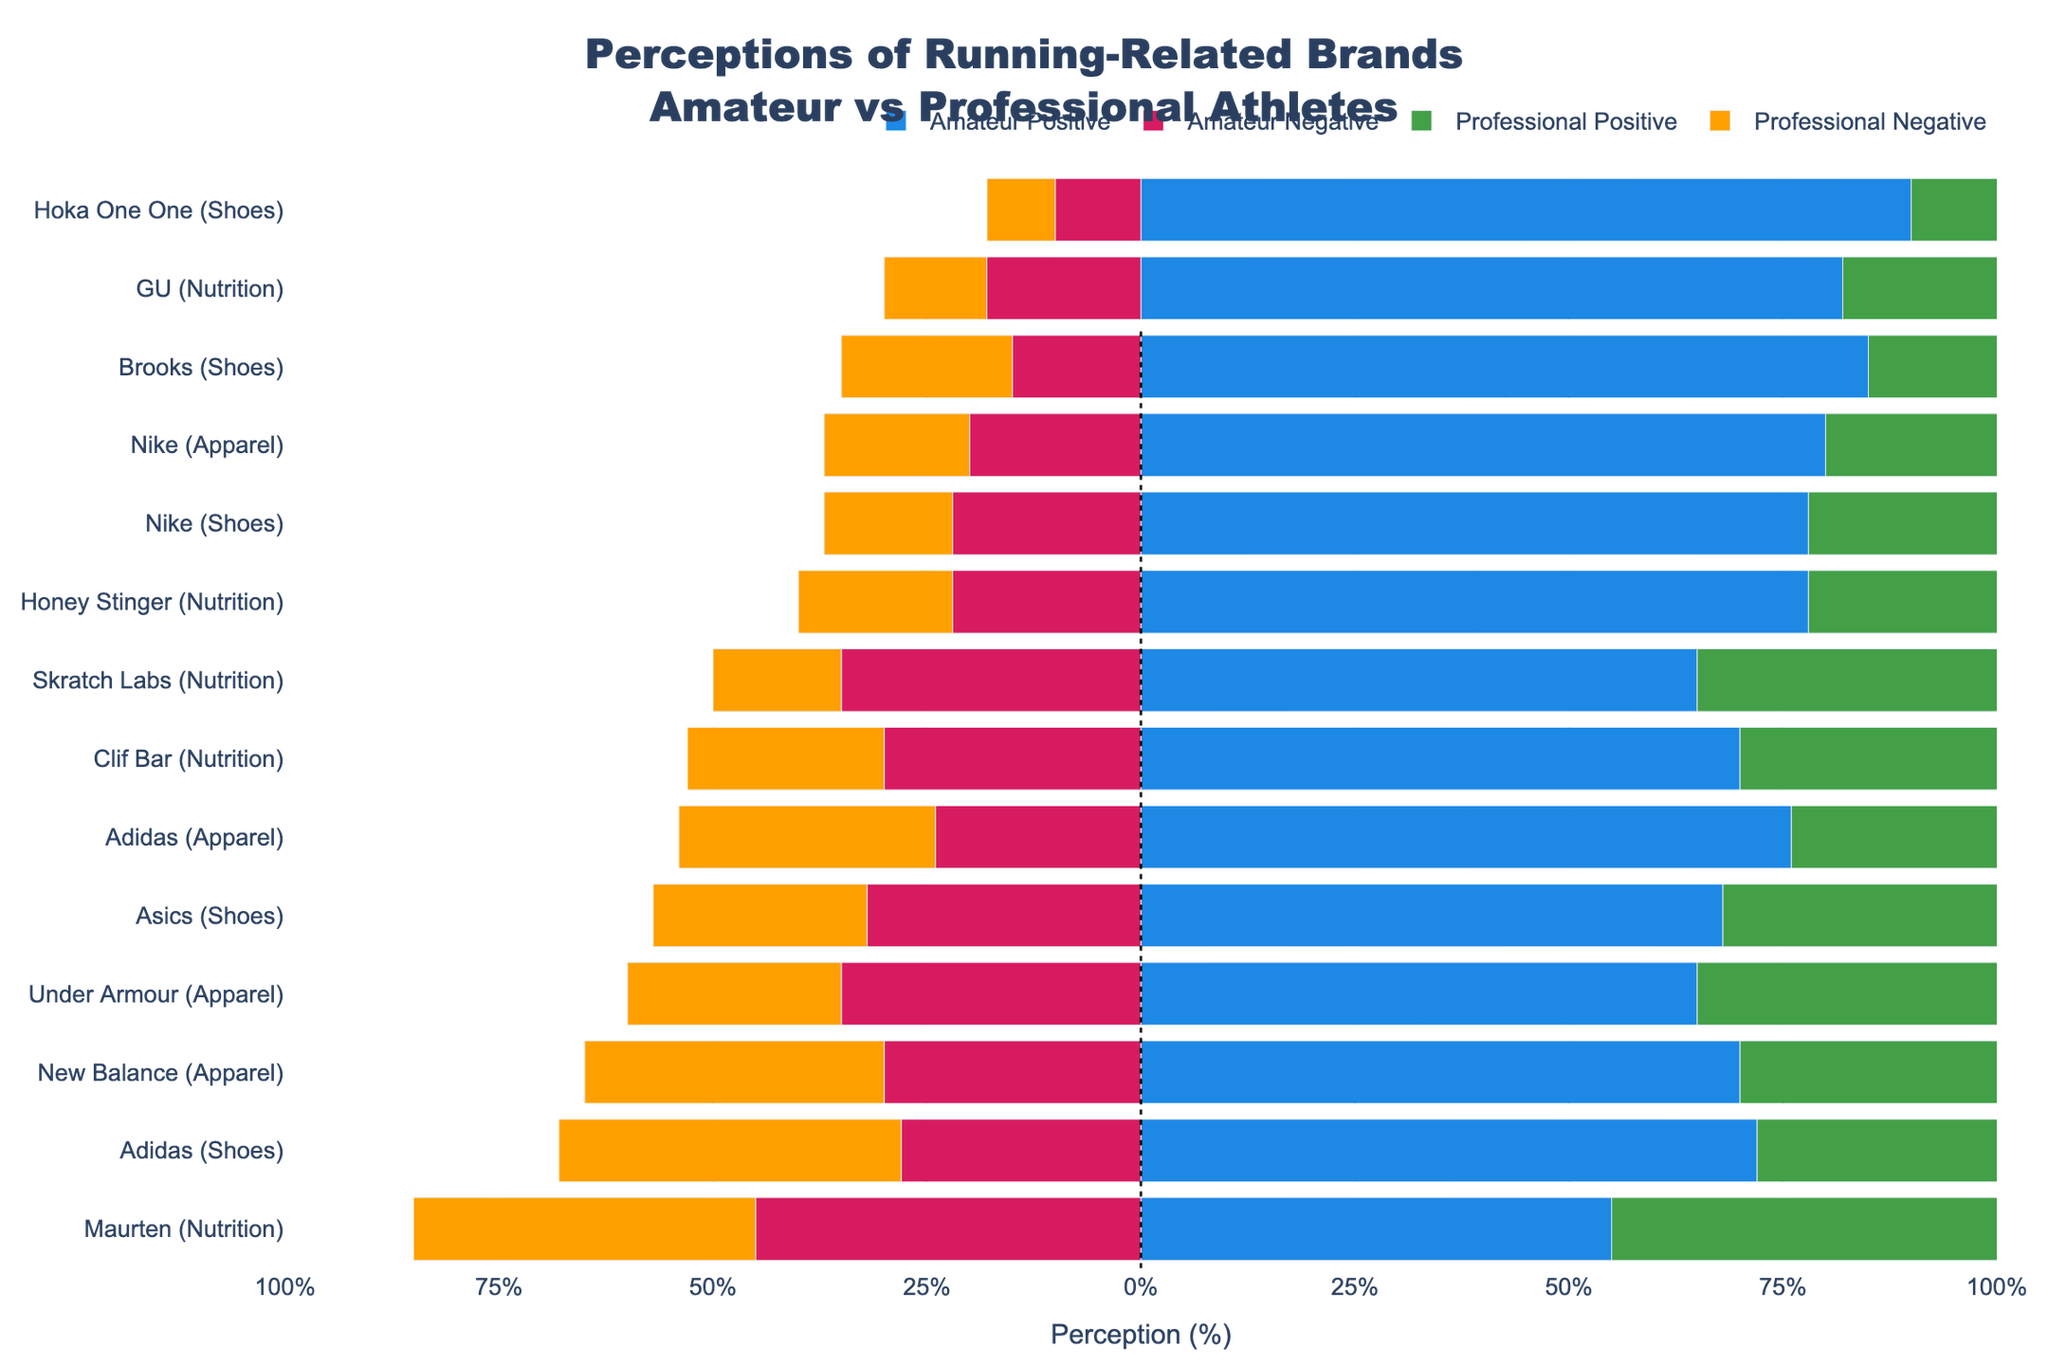Which brand has the highest positive perception among professional athletes for shoes? Look for the longest green bar under "Professional Positive" within the shoe category. Compare the values.
Answer: Hoka One One Which apparel brand has a higher negative perception among amateurs, Nike or Adidas? Compare the lengths of the red bars for Nike and Adidas within the Amateur Negative perception for the apparel category.
Answer: Adidas What is the difference in positive perception of Nike shoes between amateur and professional athletes? Subtract the positive perception value of amateurs from professionals for Nike shoes. Professionals have 85% and amateurs have 78%.
Answer: 7% Considering the nutrition brands, what is the average positive perception among professional athletes? Find the sum of the positive perception values for all nutrition brands among professionals and divide by the number of nutrition brands. Values: 88%, 82%, 77%, 85%, 60%. Average = (88+82+77+85+60)/5 = 78.4%
Answer: 78.4% Which shoe brand has the largest difference between negative perceptions of amateurs and professionals? Calculate the differences for each shoe brand and find the maximum difference. Differences: Nike (7%), Adidas (12%), Asics (7%), Brooks (5%), Hoka One One (2%).
Answer: Adidas Between Honey Stinger and Clif Bar, which brand do professional athletes perceive more positively regarding nutrition? Compare the lengths of the green bars under "Professional Positive" for both brands.
Answer: Honey Stinger Among all brands and product types, which has the least negative perception by amateur athletes? Identify the smallest red bar under Amateur Negative perception.
Answer: Hoka One One (Shoes) Is the positive perception of Asics shoes higher among professional or amateur athletes? Compare the lengths of the green bars for Asics shoes between amateur and professional athletes.
Answer: Professional Which apparel brand's negative perception is higher among professional athletes compared to amateur athletes? Compare the values for all apparel brands and identify which has a higher negative perception among professionals than amateurs.
Answer: New Balance What is the combined positive perception of GU in nutrition for both amateur and professional athletes? Add the positive perception values for amateurs and professionals for GU. Amateur: 82%, Professional: 88%. Combined = 82 + 88 = 170%
Answer: 170% 